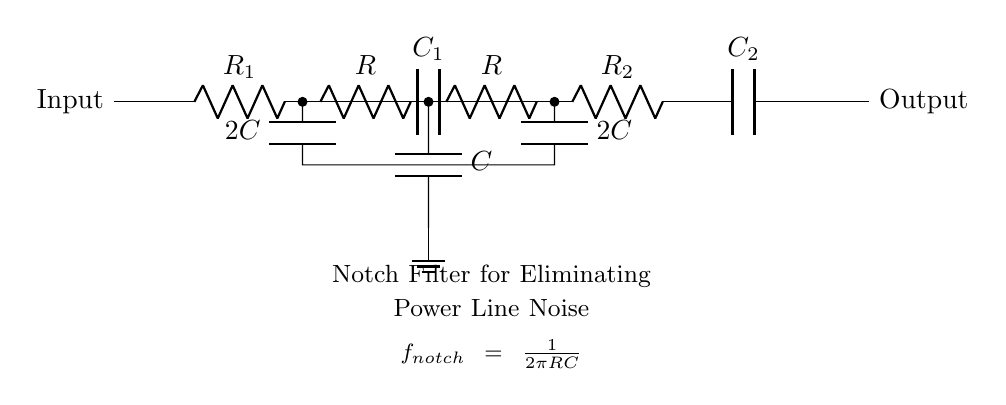What is the main function of this circuit? The main function of this circuit is to eliminate power line noise, which can interfere with sensitive measurements. This is indicated by the labeling of the circuit as a notch filter specifically designed for that purpose.
Answer: Eliminate power line noise How many resistors are in the circuit? The circuit contains four resistors: R1, R2, and two additional resistors labeled simply as R. By counting them from the diagram, one can identify these four components.
Answer: Four What is the relationship between resistance and the notch frequency? The notch frequency is inversely proportional to the product of resistance and capacitance, as shown in the formula displayed in the diagram, f_notch = 1/(2πRC). As resistance increases, the notch frequency decreases.
Answer: Inversely proportional What is the value of the capacitors used in the twin-T network? The circuit utilizes one capacitor labeled C, and two additional capacitors labeled as 2C. The values can be deduced from their respective labels in the diagram.
Answer: C and 2C What does the ground symbol represent in this circuit? The ground symbol indicates the reference point in the circuit where voltage is considered to be zero. It is essential for completing the circuit and allows for measurements of potential difference between other components and the ground.
Answer: Zero voltage reference What type of filter does this circuit represent? The circuit represents a notch filter, indicated by its specific structure intended to eliminate particular frequencies (in this case, power line noise) while allowing others to pass through unaffected.
Answer: Notch filter What is the configuration of the capacitors in the circuit? The capacitors are arranged in a way that one is in series in the path, while the other two are part of the twin-T network configuration providing the necessary frequency response for the notch filter's function.
Answer: Series and twin-T network configuration 